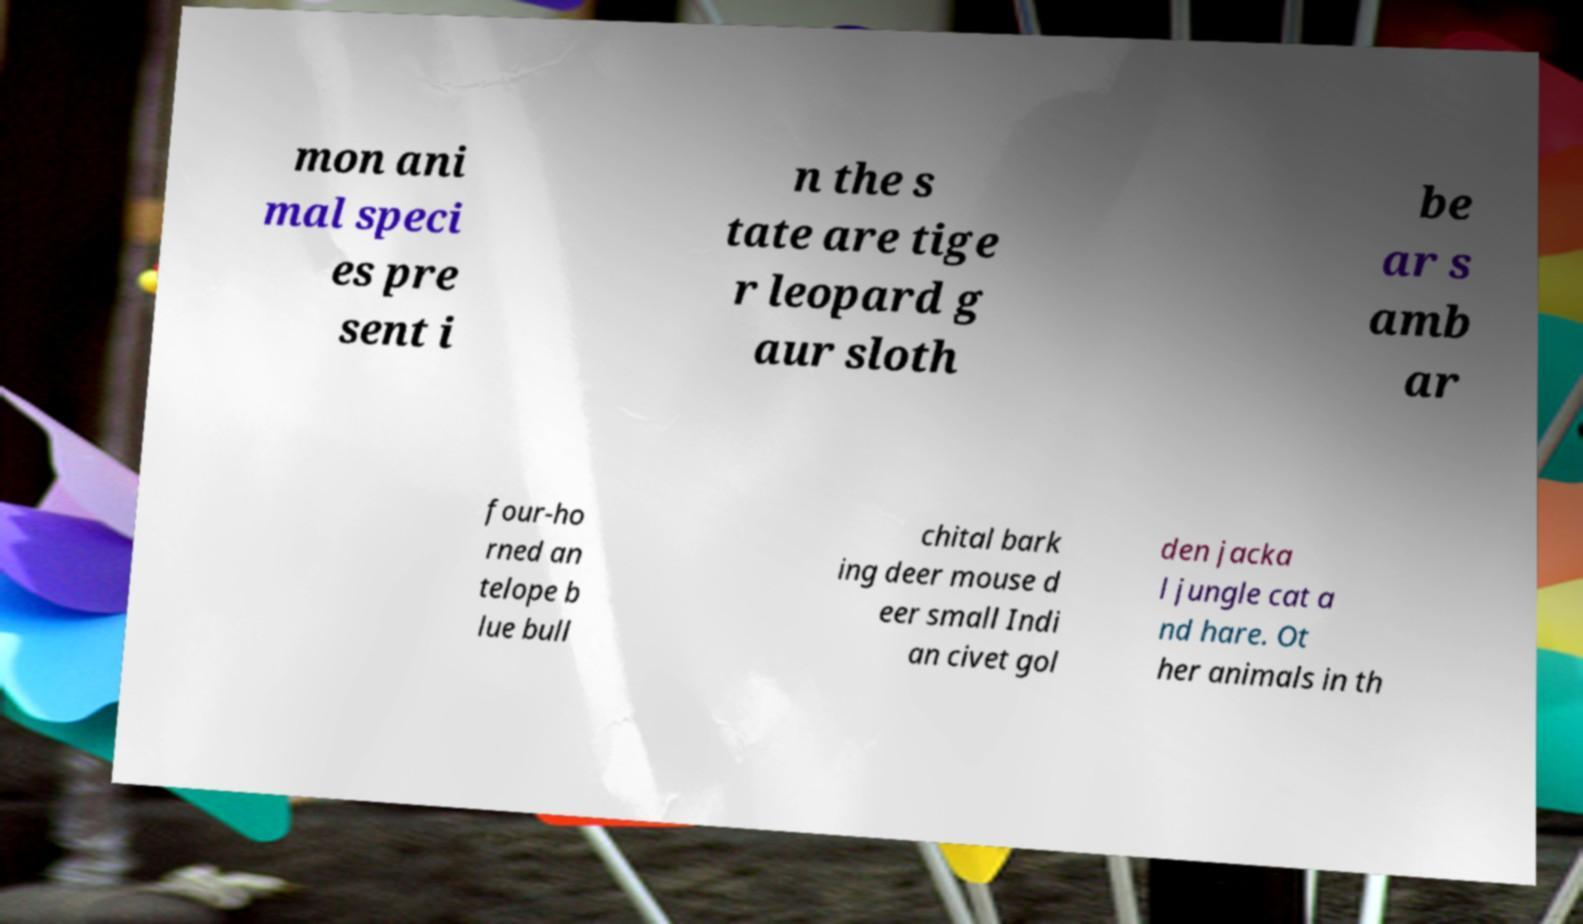There's text embedded in this image that I need extracted. Can you transcribe it verbatim? mon ani mal speci es pre sent i n the s tate are tige r leopard g aur sloth be ar s amb ar four-ho rned an telope b lue bull chital bark ing deer mouse d eer small Indi an civet gol den jacka l jungle cat a nd hare. Ot her animals in th 